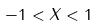<formula> <loc_0><loc_0><loc_500><loc_500>- 1 < X < 1</formula> 